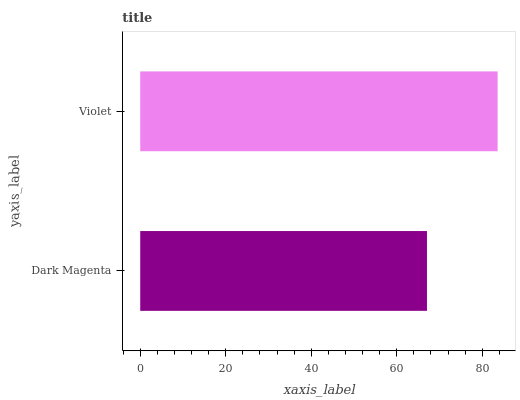Is Dark Magenta the minimum?
Answer yes or no. Yes. Is Violet the maximum?
Answer yes or no. Yes. Is Violet the minimum?
Answer yes or no. No. Is Violet greater than Dark Magenta?
Answer yes or no. Yes. Is Dark Magenta less than Violet?
Answer yes or no. Yes. Is Dark Magenta greater than Violet?
Answer yes or no. No. Is Violet less than Dark Magenta?
Answer yes or no. No. Is Violet the high median?
Answer yes or no. Yes. Is Dark Magenta the low median?
Answer yes or no. Yes. Is Dark Magenta the high median?
Answer yes or no. No. Is Violet the low median?
Answer yes or no. No. 